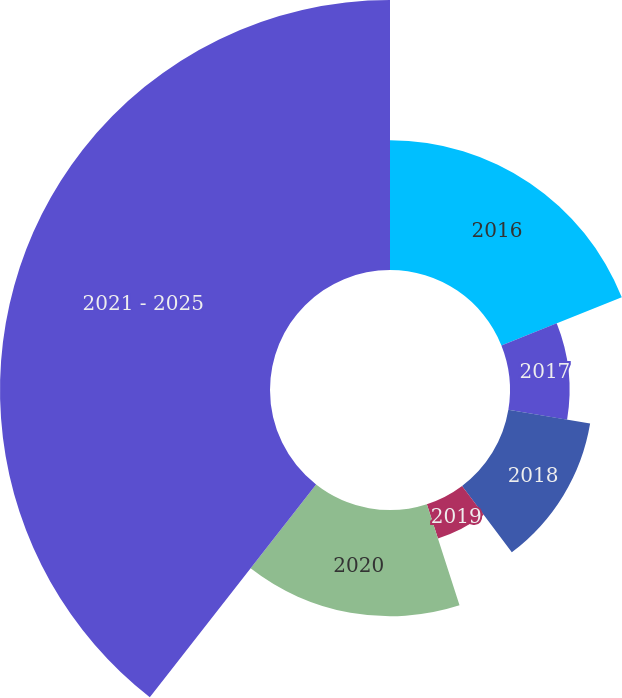Convert chart. <chart><loc_0><loc_0><loc_500><loc_500><pie_chart><fcel>2016<fcel>2017<fcel>2018<fcel>2019<fcel>2020<fcel>2021 - 2025<nl><fcel>18.94%<fcel>8.7%<fcel>12.11%<fcel>5.28%<fcel>15.53%<fcel>39.44%<nl></chart> 